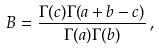Convert formula to latex. <formula><loc_0><loc_0><loc_500><loc_500>B = \frac { \Gamma ( c ) \Gamma ( a + b - c ) } { \Gamma ( a ) \Gamma ( b ) } \, ,</formula> 